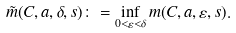Convert formula to latex. <formula><loc_0><loc_0><loc_500><loc_500>\tilde { m } ( C , a , \delta , s ) \colon = \inf _ { 0 < \varepsilon < \delta } m ( C , a , \varepsilon , s ) .</formula> 